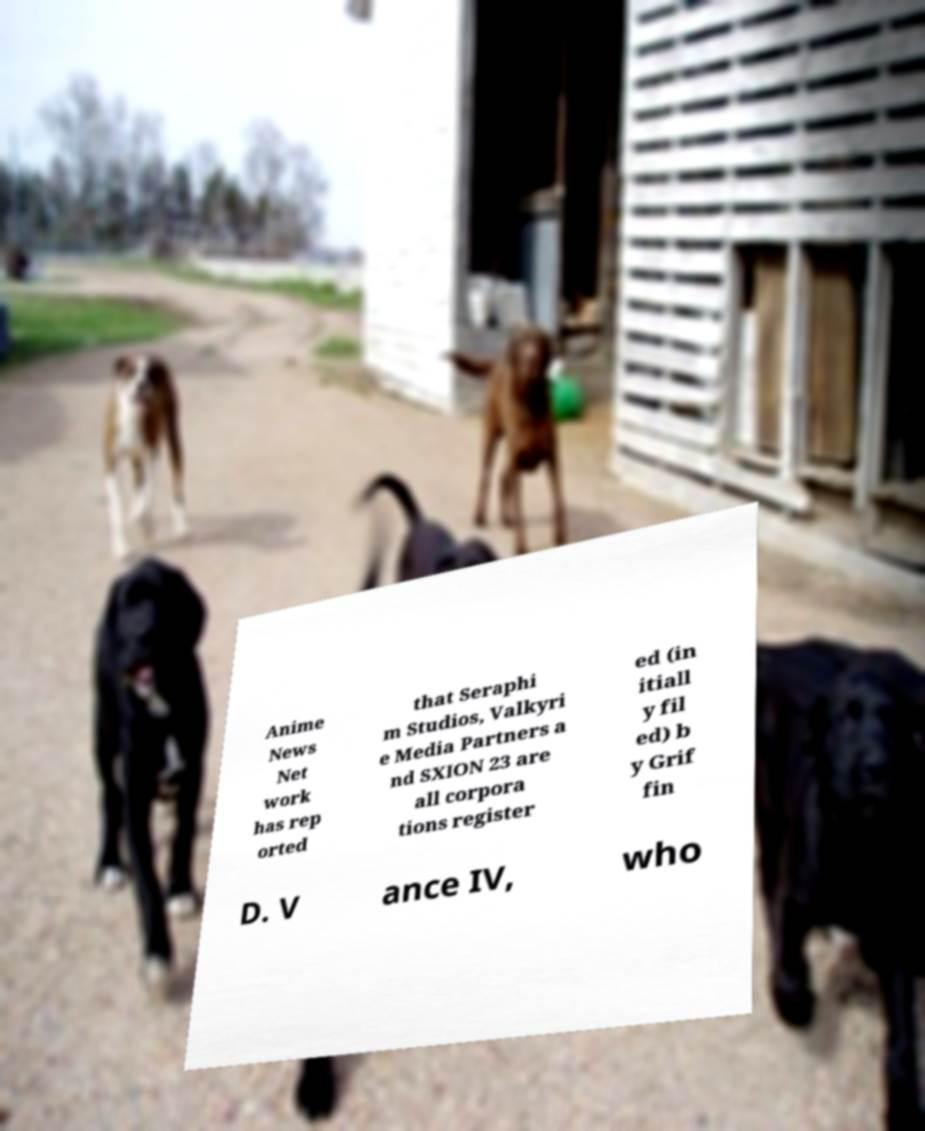Can you read and provide the text displayed in the image?This photo seems to have some interesting text. Can you extract and type it out for me? Anime News Net work has rep orted that Seraphi m Studios, Valkyri e Media Partners a nd SXION 23 are all corpora tions register ed (in itiall y fil ed) b y Grif fin D. V ance IV, who 